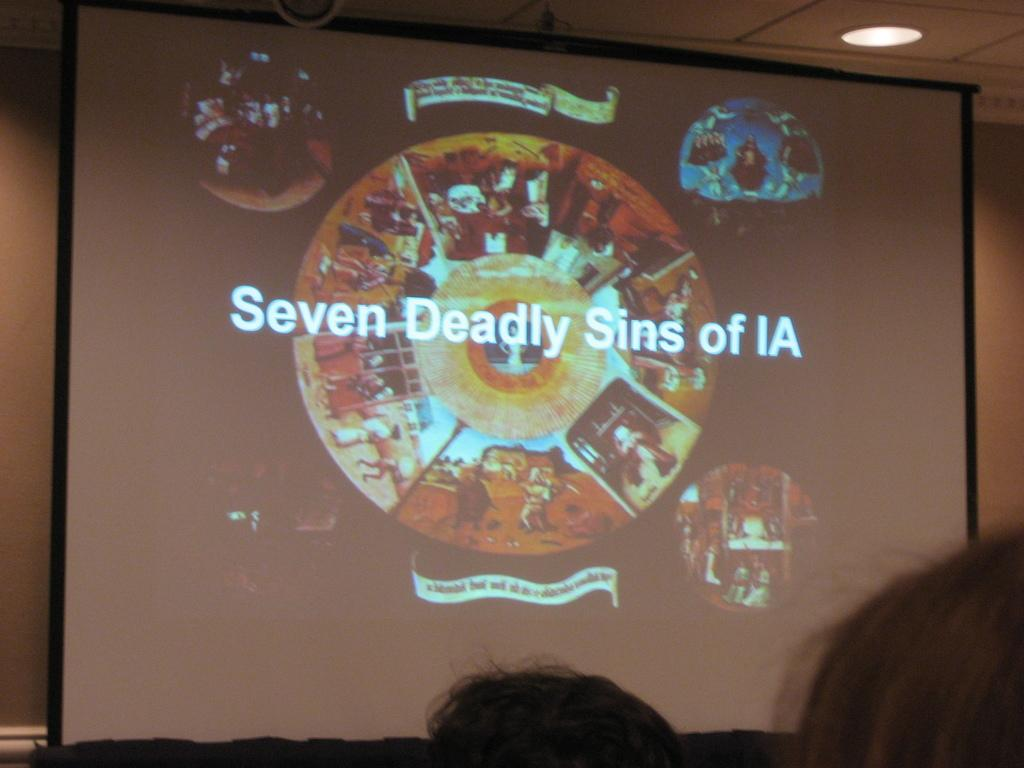What is the main object in the image? There is a screen in the image. What can be seen on the screen? There is writing and images on the screen. Where is the light located in the image? There is a light at the top of the image. What can be seen at the bottom of the image? There are people's heads visible at the bottom of the image. What type of scent can be detected in the image? There is no mention of a scent in the image, so it cannot be determined from the image. 